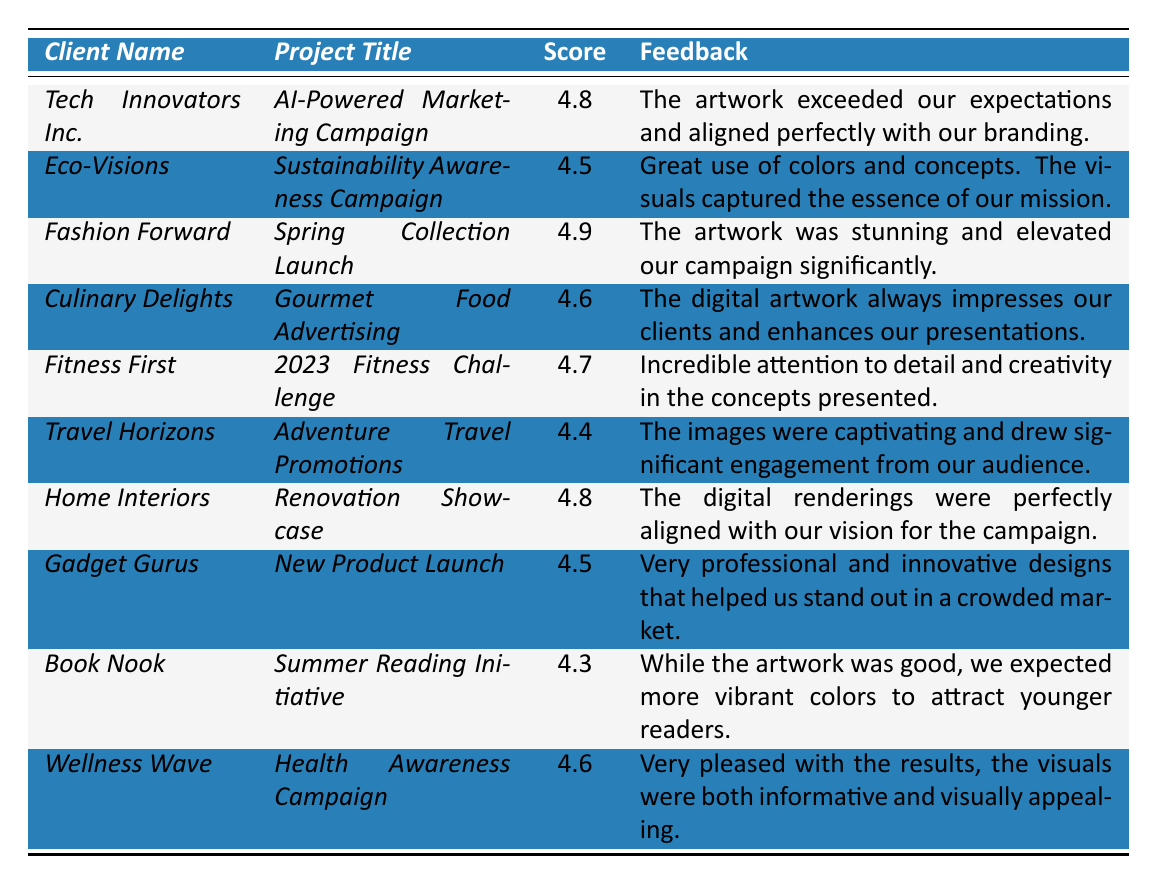What is the highest feedback score recorded in the table? The highest score is found in the row for "Fashion Forward," which has a score of 4.9.
Answer: 4.9 Which client provided feedback on a project titled "Sustainability Awareness Campaign"? The client listed under the title "Sustainability Awareness Campaign" is "Eco-Visions."
Answer: Eco-Visions How many clients received a score of 4.5 or higher? Counting the scores that are equal to or greater than 4.5: Tech Innovators Inc. (4.8), Eco-Visions (4.5), Fashion Forward (4.9), Culinary Delights (4.6), Fitness First (4.7), Travel Horizons (4.4), Home Interiors (4.8), Gadget Gurus (4.5), Wellness Wave (4.6) total 9.
Answer: 9 Is there any feedback related to "Summer Reading Initiative"? Yes, "Book Nook" provided feedback on the "Summer Reading Initiative."
Answer: Yes What is the average client score for all projects listed? Adding all the scores together yields: 4.8 + 4.5 + 4.9 + 4.6 + 4.7 + 4.4 + 4.8 + 4.5 + 4.3 + 4.6 = 46.2; dividing by 10 (the number of projects) gives an average score of 4.62.
Answer: 4.62 Which two clients provided feedback mentioning "captivating" or "captured"? "Travel Horizons" used the term "captivating," and "Eco-Visions" mentioned "captured" in their feedback.
Answer: Travel Horizons and Eco-Visions What is the overall sentiment of the feedback provided by clients? Most feedback is positive, highlighting satisfaction with the artwork terms such as "stunning," "exceeded our expectations," and "very pleased."
Answer: Positive How does the score for "Travel Horizons" compare to the average score of all projects? "Travel Horizons" has a score of 4.4, which is below the average score of 4.62, indicating it is less favorable than average.
Answer: Below average Which project received the lowest feedback score and what was the client's sentiment? The "Summer Reading Initiative" received the lowest score of 4.3. The client's sentiment suggested a desire for more vibrant colors.
Answer: Book Nook, 4.3 Did any clients express disappointment in their feedback? Yes, "Book Nook" expressed disappointment, stating they expected more vibrant colors to attract younger readers.
Answer: Yes 